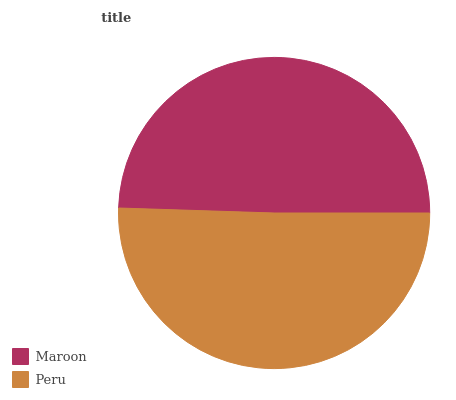Is Maroon the minimum?
Answer yes or no. Yes. Is Peru the maximum?
Answer yes or no. Yes. Is Peru the minimum?
Answer yes or no. No. Is Peru greater than Maroon?
Answer yes or no. Yes. Is Maroon less than Peru?
Answer yes or no. Yes. Is Maroon greater than Peru?
Answer yes or no. No. Is Peru less than Maroon?
Answer yes or no. No. Is Peru the high median?
Answer yes or no. Yes. Is Maroon the low median?
Answer yes or no. Yes. Is Maroon the high median?
Answer yes or no. No. Is Peru the low median?
Answer yes or no. No. 